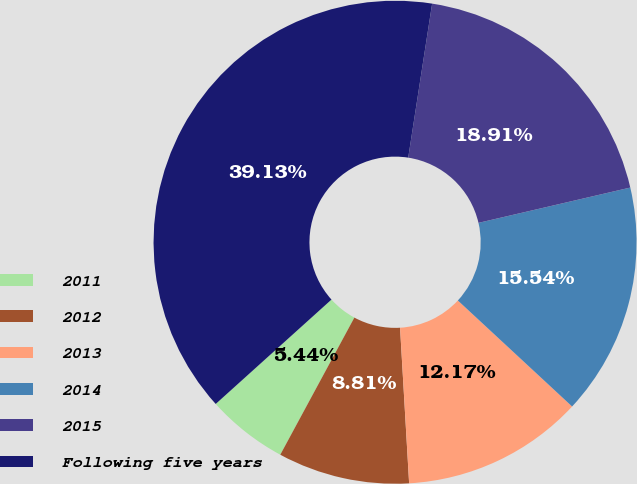Convert chart. <chart><loc_0><loc_0><loc_500><loc_500><pie_chart><fcel>2011<fcel>2012<fcel>2013<fcel>2014<fcel>2015<fcel>Following five years<nl><fcel>5.44%<fcel>8.81%<fcel>12.17%<fcel>15.54%<fcel>18.91%<fcel>39.13%<nl></chart> 